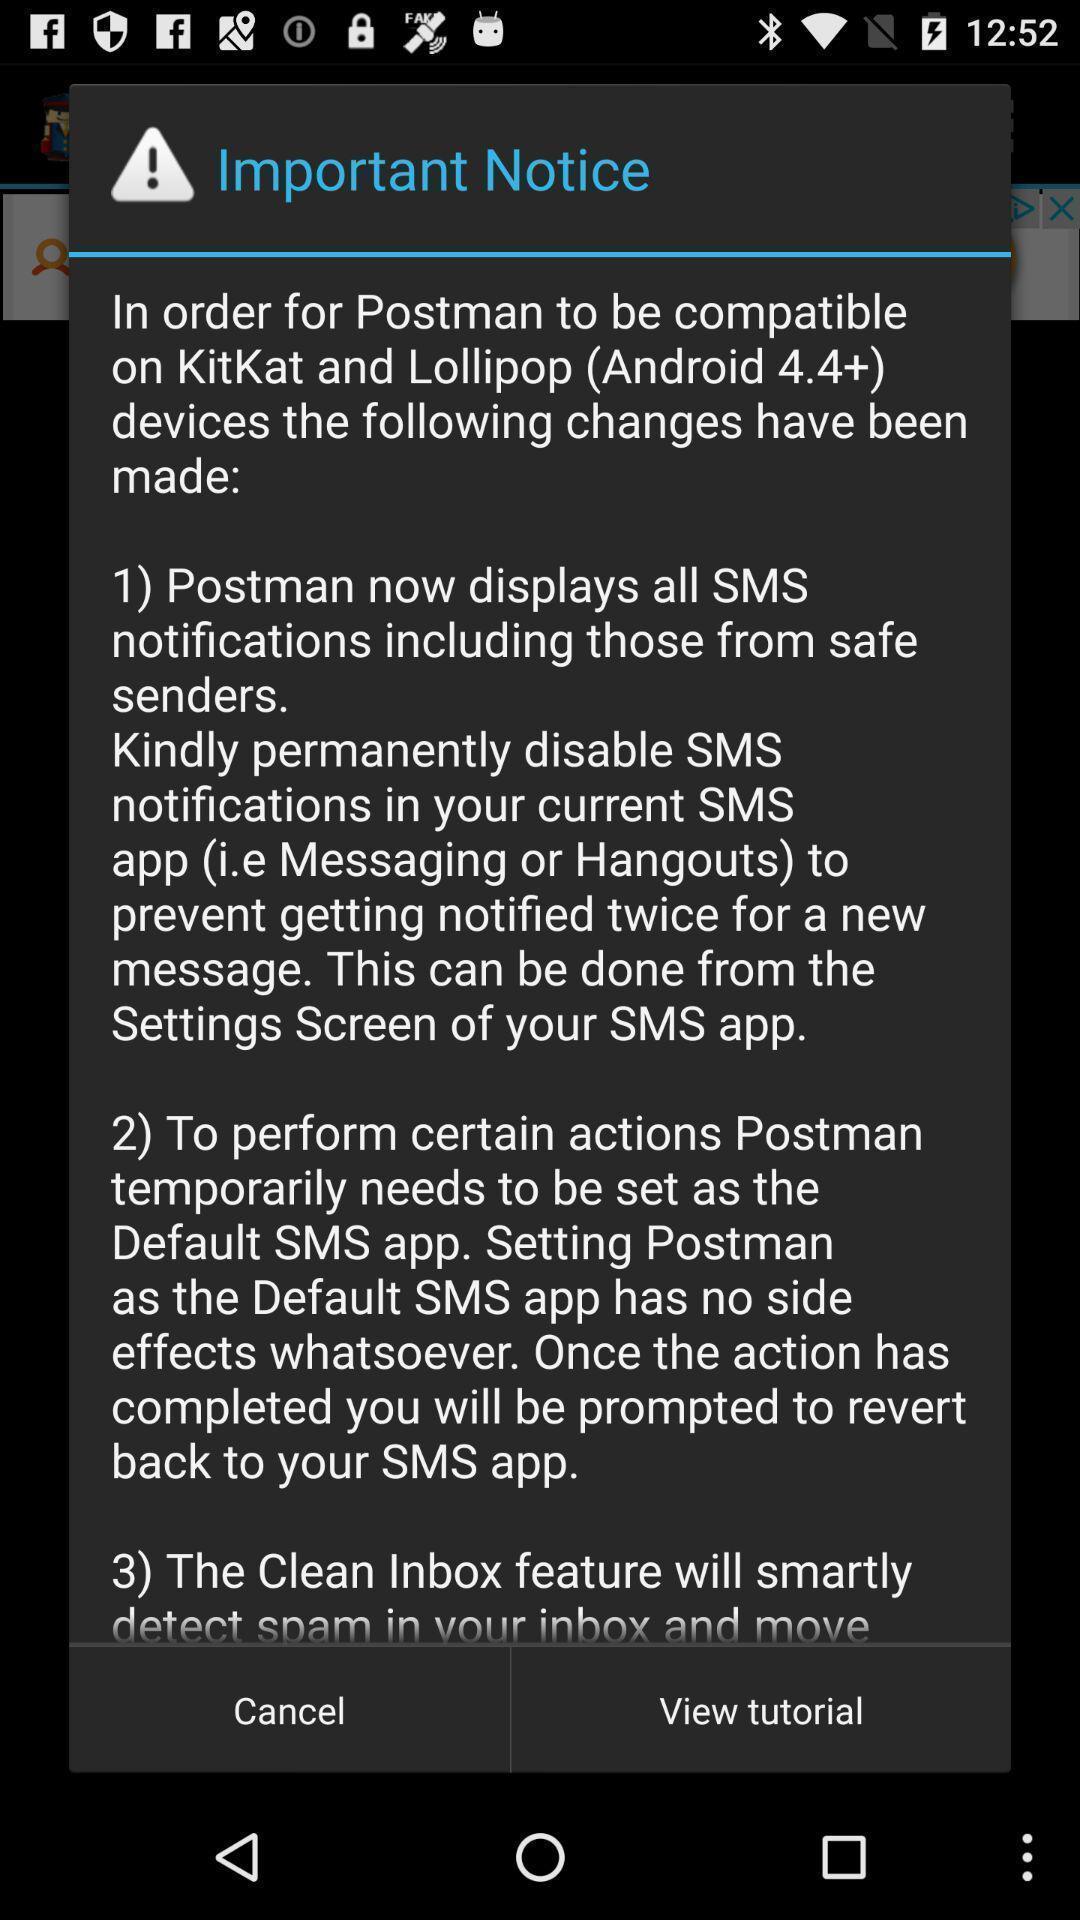Explain what's happening in this screen capture. Pop-up showing list of important notices in a learning app. 